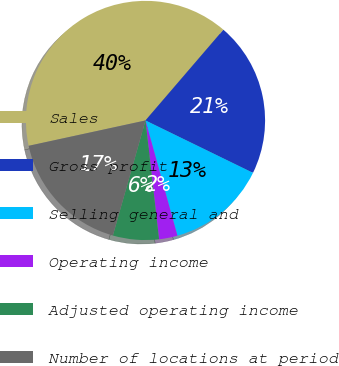<chart> <loc_0><loc_0><loc_500><loc_500><pie_chart><fcel>Sales<fcel>Gross profit<fcel>Selling general and<fcel>Operating income<fcel>Adjusted operating income<fcel>Number of locations at period<nl><fcel>39.69%<fcel>20.92%<fcel>13.48%<fcel>2.49%<fcel>6.21%<fcel>17.2%<nl></chart> 